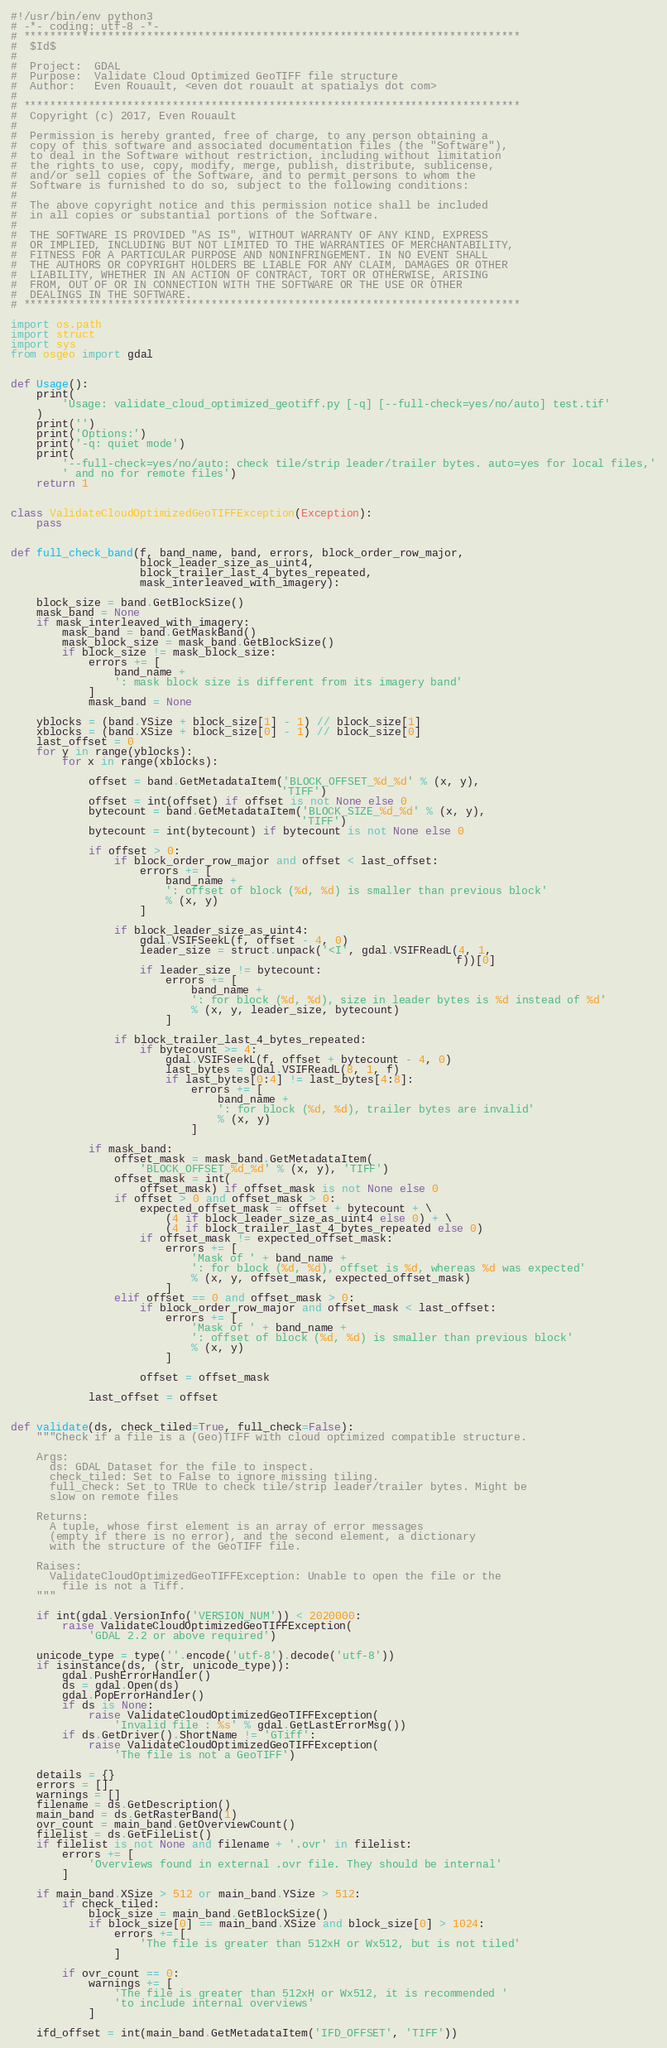Convert code to text. <code><loc_0><loc_0><loc_500><loc_500><_Python_>#!/usr/bin/env python3
# -*- coding: utf-8 -*-
# *****************************************************************************
#  $Id$
#
#  Project:  GDAL
#  Purpose:  Validate Cloud Optimized GeoTIFF file structure
#  Author:   Even Rouault, <even dot rouault at spatialys dot com>
#
# *****************************************************************************
#  Copyright (c) 2017, Even Rouault
#
#  Permission is hereby granted, free of charge, to any person obtaining a
#  copy of this software and associated documentation files (the "Software"),
#  to deal in the Software without restriction, including without limitation
#  the rights to use, copy, modify, merge, publish, distribute, sublicense,
#  and/or sell copies of the Software, and to permit persons to whom the
#  Software is furnished to do so, subject to the following conditions:
#
#  The above copyright notice and this permission notice shall be included
#  in all copies or substantial portions of the Software.
#
#  THE SOFTWARE IS PROVIDED "AS IS", WITHOUT WARRANTY OF ANY KIND, EXPRESS
#  OR IMPLIED, INCLUDING BUT NOT LIMITED TO THE WARRANTIES OF MERCHANTABILITY,
#  FITNESS FOR A PARTICULAR PURPOSE AND NONINFRINGEMENT. IN NO EVENT SHALL
#  THE AUTHORS OR COPYRIGHT HOLDERS BE LIABLE FOR ANY CLAIM, DAMAGES OR OTHER
#  LIABILITY, WHETHER IN AN ACTION OF CONTRACT, TORT OR OTHERWISE, ARISING
#  FROM, OUT OF OR IN CONNECTION WITH THE SOFTWARE OR THE USE OR OTHER
#  DEALINGS IN THE SOFTWARE.
# *****************************************************************************

import os.path
import struct
import sys
from osgeo import gdal


def Usage():
    print(
        'Usage: validate_cloud_optimized_geotiff.py [-q] [--full-check=yes/no/auto] test.tif'
    )
    print('')
    print('Options:')
    print('-q: quiet mode')
    print(
        '--full-check=yes/no/auto: check tile/strip leader/trailer bytes. auto=yes for local files,'
        ' and no for remote files')
    return 1


class ValidateCloudOptimizedGeoTIFFException(Exception):
    pass


def full_check_band(f, band_name, band, errors, block_order_row_major,
                    block_leader_size_as_uint4,
                    block_trailer_last_4_bytes_repeated,
                    mask_interleaved_with_imagery):

    block_size = band.GetBlockSize()
    mask_band = None
    if mask_interleaved_with_imagery:
        mask_band = band.GetMaskBand()
        mask_block_size = mask_band.GetBlockSize()
        if block_size != mask_block_size:
            errors += [
                band_name +
                ': mask block size is different from its imagery band'
            ]
            mask_band = None

    yblocks = (band.YSize + block_size[1] - 1) // block_size[1]
    xblocks = (band.XSize + block_size[0] - 1) // block_size[0]
    last_offset = 0
    for y in range(yblocks):
        for x in range(xblocks):

            offset = band.GetMetadataItem('BLOCK_OFFSET_%d_%d' % (x, y),
                                          'TIFF')
            offset = int(offset) if offset is not None else 0
            bytecount = band.GetMetadataItem('BLOCK_SIZE_%d_%d' % (x, y),
                                             'TIFF')
            bytecount = int(bytecount) if bytecount is not None else 0

            if offset > 0:
                if block_order_row_major and offset < last_offset:
                    errors += [
                        band_name +
                        ': offset of block (%d, %d) is smaller than previous block'
                        % (x, y)
                    ]

                if block_leader_size_as_uint4:
                    gdal.VSIFSeekL(f, offset - 4, 0)
                    leader_size = struct.unpack('<I', gdal.VSIFReadL(4, 1,
                                                                     f))[0]
                    if leader_size != bytecount:
                        errors += [
                            band_name +
                            ': for block (%d, %d), size in leader bytes is %d instead of %d'
                            % (x, y, leader_size, bytecount)
                        ]

                if block_trailer_last_4_bytes_repeated:
                    if bytecount >= 4:
                        gdal.VSIFSeekL(f, offset + bytecount - 4, 0)
                        last_bytes = gdal.VSIFReadL(8, 1, f)
                        if last_bytes[0:4] != last_bytes[4:8]:
                            errors += [
                                band_name +
                                ': for block (%d, %d), trailer bytes are invalid'
                                % (x, y)
                            ]

            if mask_band:
                offset_mask = mask_band.GetMetadataItem(
                    'BLOCK_OFFSET_%d_%d' % (x, y), 'TIFF')
                offset_mask = int(
                    offset_mask) if offset_mask is not None else 0
                if offset > 0 and offset_mask > 0:
                    expected_offset_mask = offset + bytecount + \
                        (4 if block_leader_size_as_uint4 else 0) + \
                        (4 if block_trailer_last_4_bytes_repeated else 0)
                    if offset_mask != expected_offset_mask:
                        errors += [
                            'Mask of ' + band_name +
                            ': for block (%d, %d), offset is %d, whereas %d was expected'
                            % (x, y, offset_mask, expected_offset_mask)
                        ]
                elif offset == 0 and offset_mask > 0:
                    if block_order_row_major and offset_mask < last_offset:
                        errors += [
                            'Mask of ' + band_name +
                            ': offset of block (%d, %d) is smaller than previous block'
                            % (x, y)
                        ]

                    offset = offset_mask

            last_offset = offset


def validate(ds, check_tiled=True, full_check=False):
    """Check if a file is a (Geo)TIFF with cloud optimized compatible structure.

    Args:
      ds: GDAL Dataset for the file to inspect.
      check_tiled: Set to False to ignore missing tiling.
      full_check: Set to TRUe to check tile/strip leader/trailer bytes. Might be
      slow on remote files

    Returns:
      A tuple, whose first element is an array of error messages
      (empty if there is no error), and the second element, a dictionary
      with the structure of the GeoTIFF file.

    Raises:
      ValidateCloudOptimizedGeoTIFFException: Unable to open the file or the
        file is not a Tiff.
    """

    if int(gdal.VersionInfo('VERSION_NUM')) < 2020000:
        raise ValidateCloudOptimizedGeoTIFFException(
            'GDAL 2.2 or above required')

    unicode_type = type(''.encode('utf-8').decode('utf-8'))
    if isinstance(ds, (str, unicode_type)):
        gdal.PushErrorHandler()
        ds = gdal.Open(ds)
        gdal.PopErrorHandler()
        if ds is None:
            raise ValidateCloudOptimizedGeoTIFFException(
                'Invalid file : %s' % gdal.GetLastErrorMsg())
        if ds.GetDriver().ShortName != 'GTiff':
            raise ValidateCloudOptimizedGeoTIFFException(
                'The file is not a GeoTIFF')

    details = {}
    errors = []
    warnings = []
    filename = ds.GetDescription()
    main_band = ds.GetRasterBand(1)
    ovr_count = main_band.GetOverviewCount()
    filelist = ds.GetFileList()
    if filelist is not None and filename + '.ovr' in filelist:
        errors += [
            'Overviews found in external .ovr file. They should be internal'
        ]

    if main_band.XSize > 512 or main_band.YSize > 512:
        if check_tiled:
            block_size = main_band.GetBlockSize()
            if block_size[0] == main_band.XSize and block_size[0] > 1024:
                errors += [
                    'The file is greater than 512xH or Wx512, but is not tiled'
                ]

        if ovr_count == 0:
            warnings += [
                'The file is greater than 512xH or Wx512, it is recommended '
                'to include internal overviews'
            ]

    ifd_offset = int(main_band.GetMetadataItem('IFD_OFFSET', 'TIFF'))</code> 